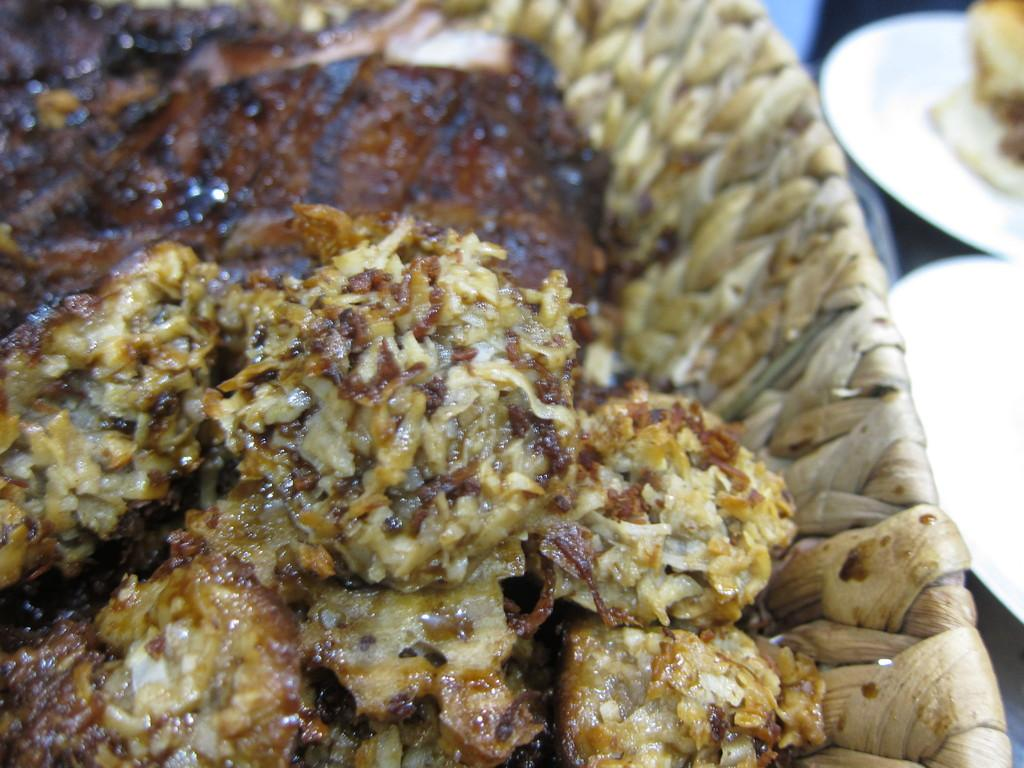What is in the bowl that is visible in the image? There is food in a bowl in the image. Where are the plates located in the image? There are two plates on the right side of the image. What is placed on the plates? There is more food placed on the plates. How many sisters are holding dolls in the image? There are no sisters or dolls present in the image. What type of popcorn can be seen in the image? There is no popcorn present in the image. 